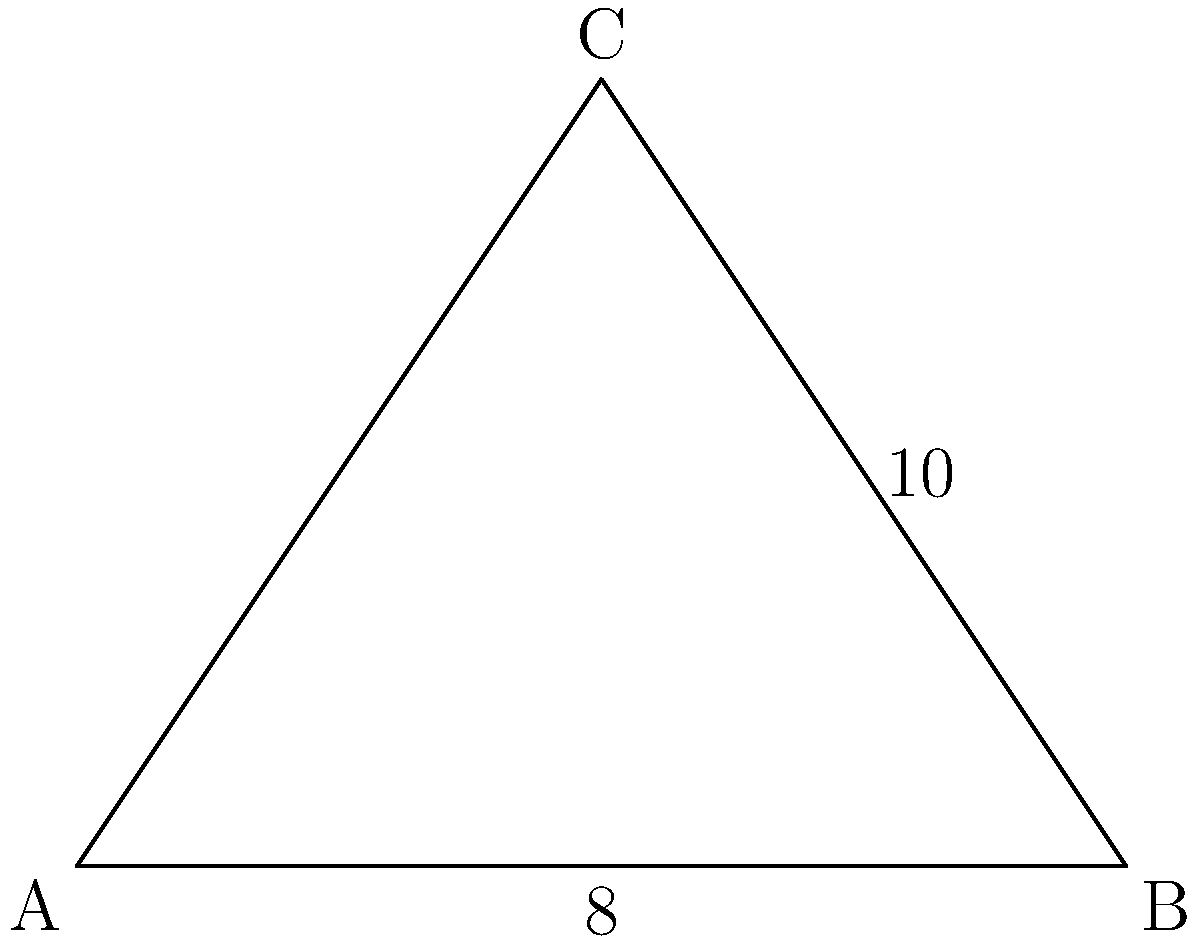During a dance performance, you and your fellow dancers form a triangular formation. The base of the triangle is 8 meters long, and the hypotenuse (the longest side) is 10 meters. What is the height of the triangular formation? Let's approach this step-by-step using the Pythagorean theorem:

1) Let's denote the height of the triangle as $h$.

2) We know:
   - The base of the triangle is 8 meters
   - The hypotenuse is 10 meters

3) In a right triangle, the Pythagorean theorem states:
   $a^2 + b^2 = c^2$
   where $c$ is the hypotenuse, and $a$ and $b$ are the other two sides.

4) In our case:
   $h^2 + 4^2 = 10^2$
   (Note: We use 4 instead of 8 because the height creates two right triangles, each with half the base)

5) Let's solve the equation:
   $h^2 + 16 = 100$
   $h^2 = 84$

6) Take the square root of both sides:
   $h = \sqrt{84}$

7) Simplify:
   $h = 2\sqrt{21} \approx 9.17$ meters

Therefore, the height of the triangular dance formation is $2\sqrt{21}$ meters or approximately 9.17 meters.
Answer: $2\sqrt{21}$ meters 